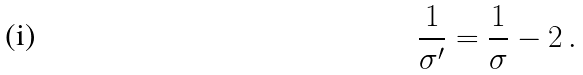<formula> <loc_0><loc_0><loc_500><loc_500>\frac { 1 } { \sigma ^ { \prime } } = \frac { 1 } { \sigma } - 2 \, .</formula> 